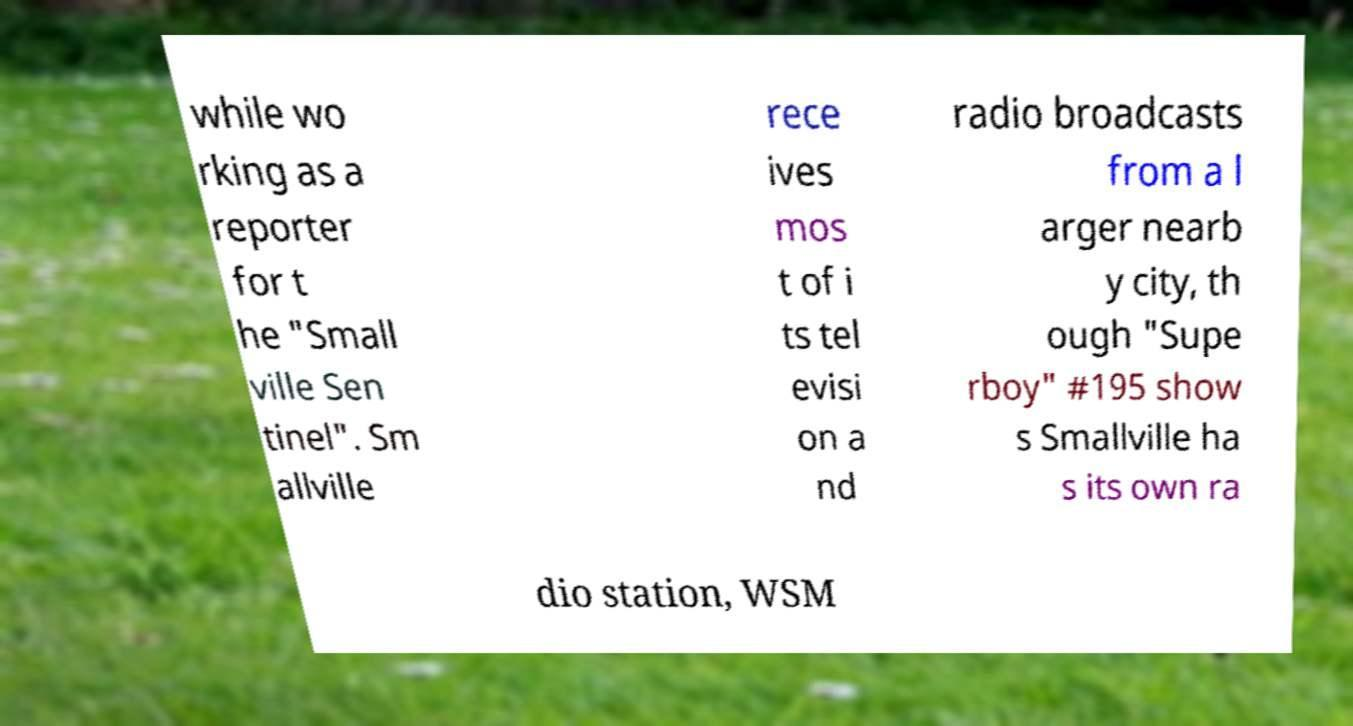Can you read and provide the text displayed in the image?This photo seems to have some interesting text. Can you extract and type it out for me? while wo rking as a reporter for t he "Small ville Sen tinel". Sm allville rece ives mos t of i ts tel evisi on a nd radio broadcasts from a l arger nearb y city, th ough "Supe rboy" #195 show s Smallville ha s its own ra dio station, WSM 